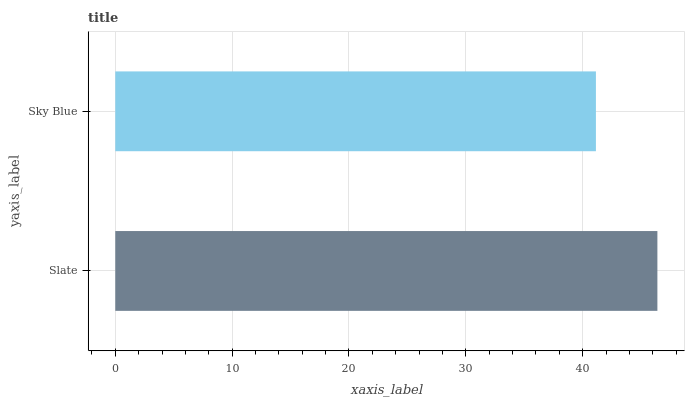Is Sky Blue the minimum?
Answer yes or no. Yes. Is Slate the maximum?
Answer yes or no. Yes. Is Sky Blue the maximum?
Answer yes or no. No. Is Slate greater than Sky Blue?
Answer yes or no. Yes. Is Sky Blue less than Slate?
Answer yes or no. Yes. Is Sky Blue greater than Slate?
Answer yes or no. No. Is Slate less than Sky Blue?
Answer yes or no. No. Is Slate the high median?
Answer yes or no. Yes. Is Sky Blue the low median?
Answer yes or no. Yes. Is Sky Blue the high median?
Answer yes or no. No. Is Slate the low median?
Answer yes or no. No. 